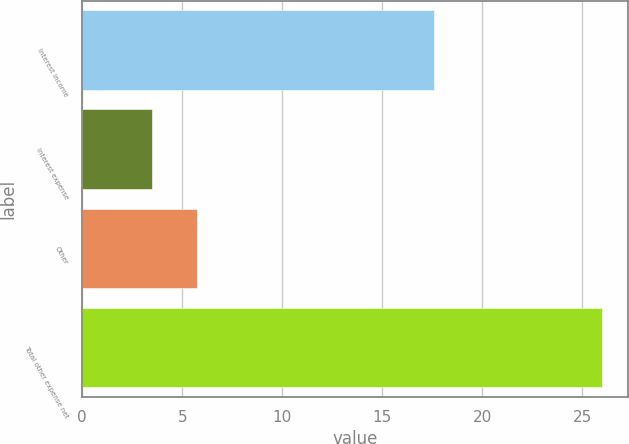Convert chart. <chart><loc_0><loc_0><loc_500><loc_500><bar_chart><fcel>Interest income<fcel>Interest expense<fcel>Other<fcel>Total other expense net<nl><fcel>17.6<fcel>3.5<fcel>5.75<fcel>26<nl></chart> 